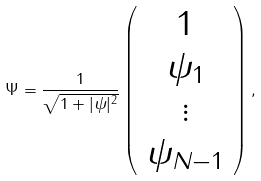Convert formula to latex. <formula><loc_0><loc_0><loc_500><loc_500>\Psi = \frac { 1 } { \sqrt { 1 + | \psi | ^ { 2 } } } \left ( \begin{array} { c } 1 \\ \psi _ { 1 } \\ \vdots \\ \psi _ { N - 1 } \end{array} \right ) ,</formula> 